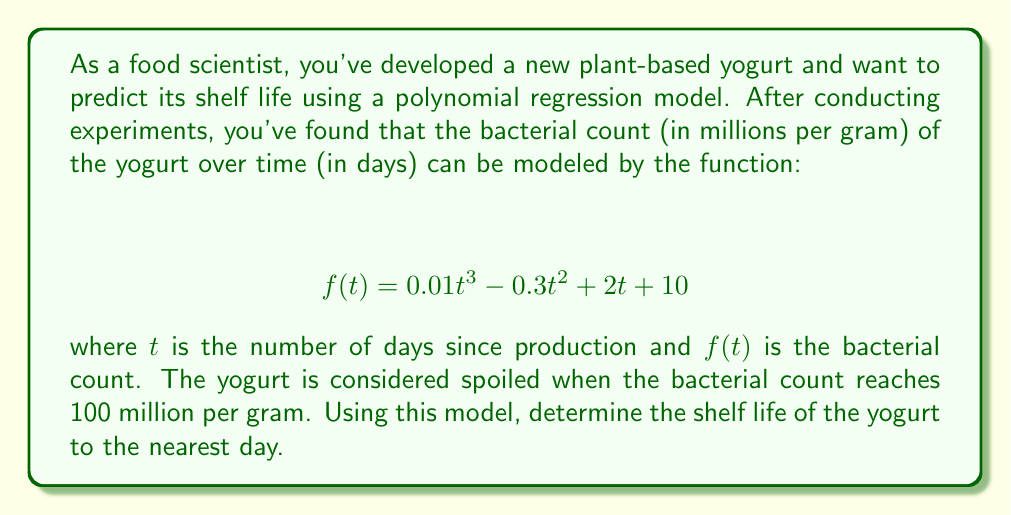Show me your answer to this math problem. To solve this problem, we need to find the value of $t$ when $f(t) = 100$. This involves solving the equation:

$$ 0.01t^3 - 0.3t^2 + 2t + 10 = 100 $$

Let's approach this step-by-step:

1) First, rearrange the equation to standard form:
   $$ 0.01t^3 - 0.3t^2 + 2t - 90 = 0 $$

2) This is a cubic equation and doesn't have a simple factored form. We'll need to use numerical methods or graphing to solve it.

3) Using a graphing calculator or computer software, we can plot the function:
   $$ y = 0.01t^3 - 0.3t^2 + 2t - 90 $$
   and find where it crosses the x-axis.

4) The graph shows that the function crosses the x-axis at approximately 13.8 days.

5) We can verify this by plugging the value back into our original function:
   $$ f(13.8) ≈ 0.01(13.8)^3 - 0.3(13.8)^2 + 2(13.8) + 10 ≈ 100.03 $$

6) Since we're asked to round to the nearest day, our answer will be 14 days.

This means that the yogurt will reach a bacterial count of 100 million per gram after approximately 14 days, which represents its shelf life.
Answer: 14 days 